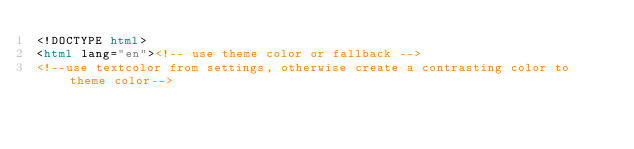Convert code to text. <code><loc_0><loc_0><loc_500><loc_500><_HTML_><!DOCTYPE html>
<html lang="en"><!-- use theme color or fallback -->
<!--use textcolor from settings, otherwise create a contrasting color to theme color--></code> 